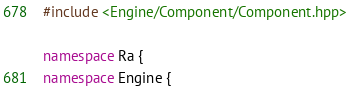<code> <loc_0><loc_0><loc_500><loc_500><_C++_>#include <Engine/Component/Component.hpp>

namespace Ra {
namespace Engine {</code> 